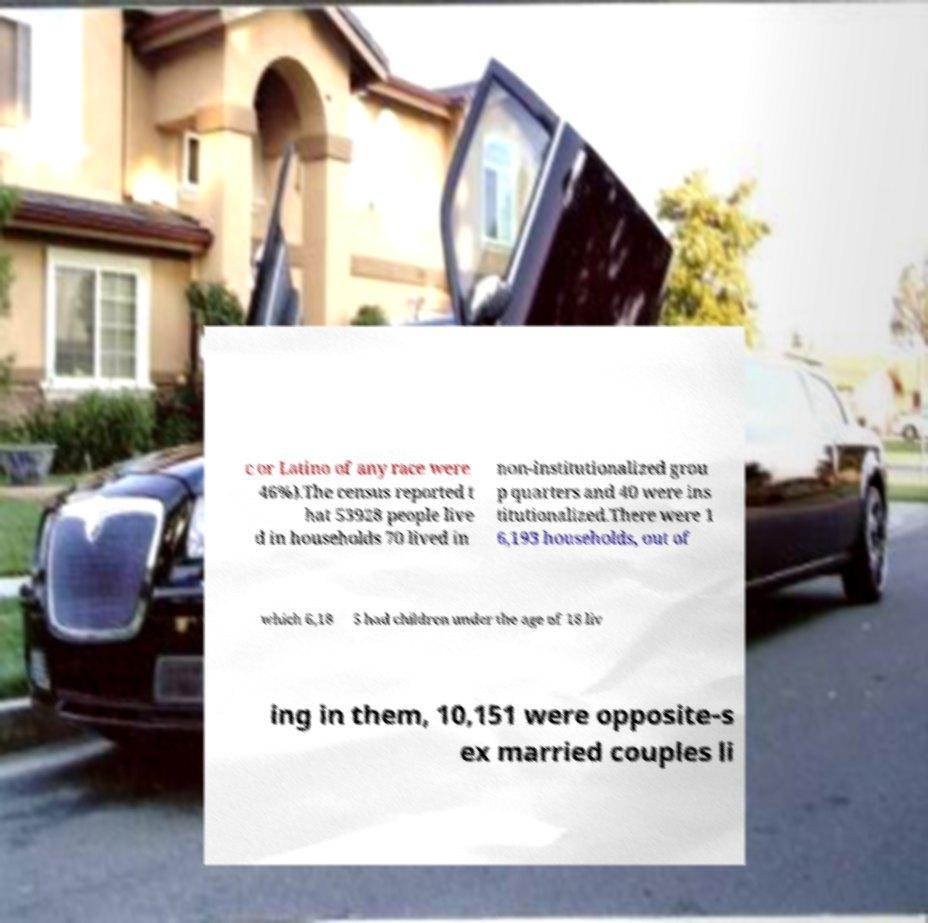There's text embedded in this image that I need extracted. Can you transcribe it verbatim? c or Latino of any race were 46%).The census reported t hat 53928 people live d in households 70 lived in non-institutionalized grou p quarters and 40 were ins titutionalized.There were 1 6,193 households, out of which 6,18 5 had children under the age of 18 liv ing in them, 10,151 were opposite-s ex married couples li 